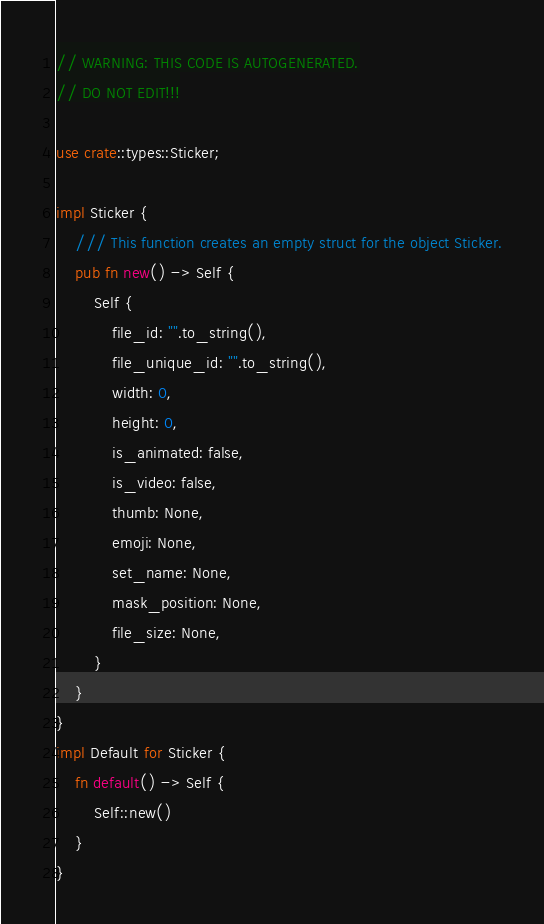Convert code to text. <code><loc_0><loc_0><loc_500><loc_500><_Rust_>// WARNING: THIS CODE IS AUTOGENERATED.
// DO NOT EDIT!!!

use crate::types::Sticker;

impl Sticker {
    /// This function creates an empty struct for the object Sticker.
    pub fn new() -> Self {
        Self {
            file_id: "".to_string(),
            file_unique_id: "".to_string(),
            width: 0,
            height: 0,
            is_animated: false,
            is_video: false,
            thumb: None,
            emoji: None,
            set_name: None,
            mask_position: None,
            file_size: None,
        }
    }
}
impl Default for Sticker {
    fn default() -> Self {
        Self::new()
    }
}
</code> 